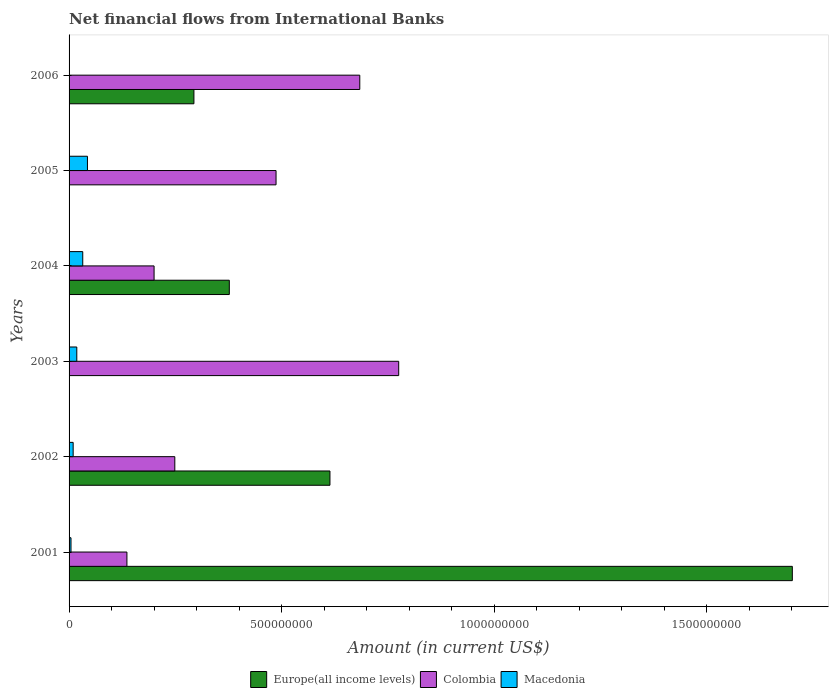How many different coloured bars are there?
Keep it short and to the point. 3. Are the number of bars on each tick of the Y-axis equal?
Offer a terse response. No. How many bars are there on the 3rd tick from the top?
Provide a short and direct response. 3. In how many cases, is the number of bars for a given year not equal to the number of legend labels?
Your response must be concise. 3. What is the net financial aid flows in Europe(all income levels) in 2006?
Offer a very short reply. 2.94e+08. Across all years, what is the maximum net financial aid flows in Macedonia?
Provide a succinct answer. 4.32e+07. Across all years, what is the minimum net financial aid flows in Colombia?
Give a very brief answer. 1.36e+08. What is the total net financial aid flows in Macedonia in the graph?
Your response must be concise. 1.08e+08. What is the difference between the net financial aid flows in Colombia in 2002 and that in 2005?
Your answer should be compact. -2.38e+08. What is the difference between the net financial aid flows in Macedonia in 2004 and the net financial aid flows in Colombia in 2006?
Provide a succinct answer. -6.52e+08. What is the average net financial aid flows in Macedonia per year?
Your response must be concise. 1.80e+07. In the year 2001, what is the difference between the net financial aid flows in Colombia and net financial aid flows in Macedonia?
Give a very brief answer. 1.32e+08. What is the ratio of the net financial aid flows in Macedonia in 2001 to that in 2005?
Your response must be concise. 0.1. What is the difference between the highest and the second highest net financial aid flows in Colombia?
Offer a terse response. 9.16e+07. What is the difference between the highest and the lowest net financial aid flows in Colombia?
Give a very brief answer. 6.39e+08. Is the sum of the net financial aid flows in Colombia in 2002 and 2006 greater than the maximum net financial aid flows in Macedonia across all years?
Provide a succinct answer. Yes. How many bars are there?
Your answer should be compact. 15. How many years are there in the graph?
Ensure brevity in your answer.  6. What is the difference between two consecutive major ticks on the X-axis?
Make the answer very short. 5.00e+08. Are the values on the major ticks of X-axis written in scientific E-notation?
Offer a terse response. No. Where does the legend appear in the graph?
Your answer should be compact. Bottom center. How many legend labels are there?
Offer a very short reply. 3. How are the legend labels stacked?
Give a very brief answer. Horizontal. What is the title of the graph?
Make the answer very short. Net financial flows from International Banks. What is the label or title of the X-axis?
Your response must be concise. Amount (in current US$). What is the label or title of the Y-axis?
Your answer should be compact. Years. What is the Amount (in current US$) of Europe(all income levels) in 2001?
Your answer should be very brief. 1.70e+09. What is the Amount (in current US$) in Colombia in 2001?
Ensure brevity in your answer.  1.36e+08. What is the Amount (in current US$) in Macedonia in 2001?
Offer a very short reply. 4.52e+06. What is the Amount (in current US$) in Europe(all income levels) in 2002?
Provide a short and direct response. 6.14e+08. What is the Amount (in current US$) in Colombia in 2002?
Ensure brevity in your answer.  2.49e+08. What is the Amount (in current US$) of Macedonia in 2002?
Provide a succinct answer. 9.62e+06. What is the Amount (in current US$) of Colombia in 2003?
Offer a very short reply. 7.75e+08. What is the Amount (in current US$) in Macedonia in 2003?
Provide a succinct answer. 1.82e+07. What is the Amount (in current US$) in Europe(all income levels) in 2004?
Make the answer very short. 3.77e+08. What is the Amount (in current US$) of Colombia in 2004?
Offer a very short reply. 2.00e+08. What is the Amount (in current US$) of Macedonia in 2004?
Offer a terse response. 3.22e+07. What is the Amount (in current US$) of Europe(all income levels) in 2005?
Your response must be concise. 0. What is the Amount (in current US$) of Colombia in 2005?
Your answer should be very brief. 4.87e+08. What is the Amount (in current US$) of Macedonia in 2005?
Keep it short and to the point. 4.32e+07. What is the Amount (in current US$) of Europe(all income levels) in 2006?
Provide a succinct answer. 2.94e+08. What is the Amount (in current US$) in Colombia in 2006?
Offer a very short reply. 6.84e+08. What is the Amount (in current US$) in Macedonia in 2006?
Give a very brief answer. 0. Across all years, what is the maximum Amount (in current US$) of Europe(all income levels)?
Your response must be concise. 1.70e+09. Across all years, what is the maximum Amount (in current US$) in Colombia?
Ensure brevity in your answer.  7.75e+08. Across all years, what is the maximum Amount (in current US$) of Macedonia?
Make the answer very short. 4.32e+07. Across all years, what is the minimum Amount (in current US$) in Colombia?
Your answer should be very brief. 1.36e+08. What is the total Amount (in current US$) in Europe(all income levels) in the graph?
Give a very brief answer. 2.99e+09. What is the total Amount (in current US$) in Colombia in the graph?
Your answer should be very brief. 2.53e+09. What is the total Amount (in current US$) of Macedonia in the graph?
Provide a short and direct response. 1.08e+08. What is the difference between the Amount (in current US$) in Europe(all income levels) in 2001 and that in 2002?
Your answer should be very brief. 1.09e+09. What is the difference between the Amount (in current US$) of Colombia in 2001 and that in 2002?
Make the answer very short. -1.13e+08. What is the difference between the Amount (in current US$) in Macedonia in 2001 and that in 2002?
Keep it short and to the point. -5.10e+06. What is the difference between the Amount (in current US$) of Colombia in 2001 and that in 2003?
Give a very brief answer. -6.39e+08. What is the difference between the Amount (in current US$) of Macedonia in 2001 and that in 2003?
Make the answer very short. -1.37e+07. What is the difference between the Amount (in current US$) in Europe(all income levels) in 2001 and that in 2004?
Make the answer very short. 1.32e+09. What is the difference between the Amount (in current US$) in Colombia in 2001 and that in 2004?
Your answer should be very brief. -6.39e+07. What is the difference between the Amount (in current US$) in Macedonia in 2001 and that in 2004?
Make the answer very short. -2.77e+07. What is the difference between the Amount (in current US$) of Colombia in 2001 and that in 2005?
Your response must be concise. -3.51e+08. What is the difference between the Amount (in current US$) of Macedonia in 2001 and that in 2005?
Your answer should be very brief. -3.87e+07. What is the difference between the Amount (in current US$) in Europe(all income levels) in 2001 and that in 2006?
Make the answer very short. 1.41e+09. What is the difference between the Amount (in current US$) in Colombia in 2001 and that in 2006?
Your answer should be very brief. -5.48e+08. What is the difference between the Amount (in current US$) of Colombia in 2002 and that in 2003?
Offer a very short reply. -5.27e+08. What is the difference between the Amount (in current US$) in Macedonia in 2002 and that in 2003?
Give a very brief answer. -8.56e+06. What is the difference between the Amount (in current US$) of Europe(all income levels) in 2002 and that in 2004?
Provide a short and direct response. 2.37e+08. What is the difference between the Amount (in current US$) of Colombia in 2002 and that in 2004?
Your answer should be compact. 4.88e+07. What is the difference between the Amount (in current US$) in Macedonia in 2002 and that in 2004?
Your answer should be compact. -2.26e+07. What is the difference between the Amount (in current US$) in Colombia in 2002 and that in 2005?
Provide a succinct answer. -2.38e+08. What is the difference between the Amount (in current US$) in Macedonia in 2002 and that in 2005?
Your response must be concise. -3.36e+07. What is the difference between the Amount (in current US$) of Europe(all income levels) in 2002 and that in 2006?
Give a very brief answer. 3.20e+08. What is the difference between the Amount (in current US$) in Colombia in 2002 and that in 2006?
Your answer should be compact. -4.35e+08. What is the difference between the Amount (in current US$) in Colombia in 2003 and that in 2004?
Offer a very short reply. 5.76e+08. What is the difference between the Amount (in current US$) in Macedonia in 2003 and that in 2004?
Offer a very short reply. -1.40e+07. What is the difference between the Amount (in current US$) of Colombia in 2003 and that in 2005?
Your answer should be compact. 2.89e+08. What is the difference between the Amount (in current US$) in Macedonia in 2003 and that in 2005?
Your response must be concise. -2.51e+07. What is the difference between the Amount (in current US$) of Colombia in 2003 and that in 2006?
Your answer should be compact. 9.16e+07. What is the difference between the Amount (in current US$) in Colombia in 2004 and that in 2005?
Make the answer very short. -2.87e+08. What is the difference between the Amount (in current US$) of Macedonia in 2004 and that in 2005?
Your answer should be compact. -1.10e+07. What is the difference between the Amount (in current US$) of Europe(all income levels) in 2004 and that in 2006?
Your response must be concise. 8.33e+07. What is the difference between the Amount (in current US$) in Colombia in 2004 and that in 2006?
Give a very brief answer. -4.84e+08. What is the difference between the Amount (in current US$) of Colombia in 2005 and that in 2006?
Give a very brief answer. -1.97e+08. What is the difference between the Amount (in current US$) of Europe(all income levels) in 2001 and the Amount (in current US$) of Colombia in 2002?
Provide a succinct answer. 1.45e+09. What is the difference between the Amount (in current US$) in Europe(all income levels) in 2001 and the Amount (in current US$) in Macedonia in 2002?
Ensure brevity in your answer.  1.69e+09. What is the difference between the Amount (in current US$) of Colombia in 2001 and the Amount (in current US$) of Macedonia in 2002?
Give a very brief answer. 1.26e+08. What is the difference between the Amount (in current US$) in Europe(all income levels) in 2001 and the Amount (in current US$) in Colombia in 2003?
Keep it short and to the point. 9.26e+08. What is the difference between the Amount (in current US$) in Europe(all income levels) in 2001 and the Amount (in current US$) in Macedonia in 2003?
Keep it short and to the point. 1.68e+09. What is the difference between the Amount (in current US$) in Colombia in 2001 and the Amount (in current US$) in Macedonia in 2003?
Give a very brief answer. 1.18e+08. What is the difference between the Amount (in current US$) in Europe(all income levels) in 2001 and the Amount (in current US$) in Colombia in 2004?
Your response must be concise. 1.50e+09. What is the difference between the Amount (in current US$) in Europe(all income levels) in 2001 and the Amount (in current US$) in Macedonia in 2004?
Your answer should be compact. 1.67e+09. What is the difference between the Amount (in current US$) in Colombia in 2001 and the Amount (in current US$) in Macedonia in 2004?
Keep it short and to the point. 1.04e+08. What is the difference between the Amount (in current US$) in Europe(all income levels) in 2001 and the Amount (in current US$) in Colombia in 2005?
Make the answer very short. 1.21e+09. What is the difference between the Amount (in current US$) of Europe(all income levels) in 2001 and the Amount (in current US$) of Macedonia in 2005?
Ensure brevity in your answer.  1.66e+09. What is the difference between the Amount (in current US$) of Colombia in 2001 and the Amount (in current US$) of Macedonia in 2005?
Ensure brevity in your answer.  9.29e+07. What is the difference between the Amount (in current US$) of Europe(all income levels) in 2001 and the Amount (in current US$) of Colombia in 2006?
Your response must be concise. 1.02e+09. What is the difference between the Amount (in current US$) in Europe(all income levels) in 2002 and the Amount (in current US$) in Colombia in 2003?
Provide a succinct answer. -1.62e+08. What is the difference between the Amount (in current US$) of Europe(all income levels) in 2002 and the Amount (in current US$) of Macedonia in 2003?
Give a very brief answer. 5.96e+08. What is the difference between the Amount (in current US$) of Colombia in 2002 and the Amount (in current US$) of Macedonia in 2003?
Keep it short and to the point. 2.31e+08. What is the difference between the Amount (in current US$) of Europe(all income levels) in 2002 and the Amount (in current US$) of Colombia in 2004?
Provide a short and direct response. 4.14e+08. What is the difference between the Amount (in current US$) in Europe(all income levels) in 2002 and the Amount (in current US$) in Macedonia in 2004?
Provide a short and direct response. 5.82e+08. What is the difference between the Amount (in current US$) of Colombia in 2002 and the Amount (in current US$) of Macedonia in 2004?
Your answer should be very brief. 2.17e+08. What is the difference between the Amount (in current US$) in Europe(all income levels) in 2002 and the Amount (in current US$) in Colombia in 2005?
Offer a very short reply. 1.27e+08. What is the difference between the Amount (in current US$) in Europe(all income levels) in 2002 and the Amount (in current US$) in Macedonia in 2005?
Provide a short and direct response. 5.71e+08. What is the difference between the Amount (in current US$) in Colombia in 2002 and the Amount (in current US$) in Macedonia in 2005?
Ensure brevity in your answer.  2.06e+08. What is the difference between the Amount (in current US$) of Europe(all income levels) in 2002 and the Amount (in current US$) of Colombia in 2006?
Your response must be concise. -7.02e+07. What is the difference between the Amount (in current US$) of Colombia in 2003 and the Amount (in current US$) of Macedonia in 2004?
Provide a short and direct response. 7.43e+08. What is the difference between the Amount (in current US$) in Colombia in 2003 and the Amount (in current US$) in Macedonia in 2005?
Your answer should be very brief. 7.32e+08. What is the difference between the Amount (in current US$) in Europe(all income levels) in 2004 and the Amount (in current US$) in Colombia in 2005?
Your response must be concise. -1.10e+08. What is the difference between the Amount (in current US$) in Europe(all income levels) in 2004 and the Amount (in current US$) in Macedonia in 2005?
Ensure brevity in your answer.  3.34e+08. What is the difference between the Amount (in current US$) in Colombia in 2004 and the Amount (in current US$) in Macedonia in 2005?
Give a very brief answer. 1.57e+08. What is the difference between the Amount (in current US$) of Europe(all income levels) in 2004 and the Amount (in current US$) of Colombia in 2006?
Give a very brief answer. -3.07e+08. What is the average Amount (in current US$) of Europe(all income levels) per year?
Provide a short and direct response. 4.98e+08. What is the average Amount (in current US$) in Colombia per year?
Give a very brief answer. 4.22e+08. What is the average Amount (in current US$) of Macedonia per year?
Your answer should be compact. 1.80e+07. In the year 2001, what is the difference between the Amount (in current US$) of Europe(all income levels) and Amount (in current US$) of Colombia?
Provide a short and direct response. 1.57e+09. In the year 2001, what is the difference between the Amount (in current US$) in Europe(all income levels) and Amount (in current US$) in Macedonia?
Provide a succinct answer. 1.70e+09. In the year 2001, what is the difference between the Amount (in current US$) of Colombia and Amount (in current US$) of Macedonia?
Make the answer very short. 1.32e+08. In the year 2002, what is the difference between the Amount (in current US$) of Europe(all income levels) and Amount (in current US$) of Colombia?
Give a very brief answer. 3.65e+08. In the year 2002, what is the difference between the Amount (in current US$) in Europe(all income levels) and Amount (in current US$) in Macedonia?
Ensure brevity in your answer.  6.04e+08. In the year 2002, what is the difference between the Amount (in current US$) in Colombia and Amount (in current US$) in Macedonia?
Make the answer very short. 2.39e+08. In the year 2003, what is the difference between the Amount (in current US$) in Colombia and Amount (in current US$) in Macedonia?
Your answer should be very brief. 7.57e+08. In the year 2004, what is the difference between the Amount (in current US$) of Europe(all income levels) and Amount (in current US$) of Colombia?
Ensure brevity in your answer.  1.77e+08. In the year 2004, what is the difference between the Amount (in current US$) in Europe(all income levels) and Amount (in current US$) in Macedonia?
Make the answer very short. 3.45e+08. In the year 2004, what is the difference between the Amount (in current US$) in Colombia and Amount (in current US$) in Macedonia?
Ensure brevity in your answer.  1.68e+08. In the year 2005, what is the difference between the Amount (in current US$) in Colombia and Amount (in current US$) in Macedonia?
Make the answer very short. 4.44e+08. In the year 2006, what is the difference between the Amount (in current US$) of Europe(all income levels) and Amount (in current US$) of Colombia?
Your answer should be compact. -3.90e+08. What is the ratio of the Amount (in current US$) of Europe(all income levels) in 2001 to that in 2002?
Keep it short and to the point. 2.77. What is the ratio of the Amount (in current US$) of Colombia in 2001 to that in 2002?
Your response must be concise. 0.55. What is the ratio of the Amount (in current US$) in Macedonia in 2001 to that in 2002?
Provide a short and direct response. 0.47. What is the ratio of the Amount (in current US$) of Colombia in 2001 to that in 2003?
Ensure brevity in your answer.  0.18. What is the ratio of the Amount (in current US$) of Macedonia in 2001 to that in 2003?
Your answer should be very brief. 0.25. What is the ratio of the Amount (in current US$) of Europe(all income levels) in 2001 to that in 2004?
Your response must be concise. 4.51. What is the ratio of the Amount (in current US$) of Colombia in 2001 to that in 2004?
Give a very brief answer. 0.68. What is the ratio of the Amount (in current US$) in Macedonia in 2001 to that in 2004?
Ensure brevity in your answer.  0.14. What is the ratio of the Amount (in current US$) of Colombia in 2001 to that in 2005?
Ensure brevity in your answer.  0.28. What is the ratio of the Amount (in current US$) in Macedonia in 2001 to that in 2005?
Your response must be concise. 0.1. What is the ratio of the Amount (in current US$) of Europe(all income levels) in 2001 to that in 2006?
Ensure brevity in your answer.  5.79. What is the ratio of the Amount (in current US$) in Colombia in 2001 to that in 2006?
Provide a succinct answer. 0.2. What is the ratio of the Amount (in current US$) in Colombia in 2002 to that in 2003?
Provide a succinct answer. 0.32. What is the ratio of the Amount (in current US$) in Macedonia in 2002 to that in 2003?
Ensure brevity in your answer.  0.53. What is the ratio of the Amount (in current US$) of Europe(all income levels) in 2002 to that in 2004?
Keep it short and to the point. 1.63. What is the ratio of the Amount (in current US$) in Colombia in 2002 to that in 2004?
Your answer should be very brief. 1.24. What is the ratio of the Amount (in current US$) in Macedonia in 2002 to that in 2004?
Offer a very short reply. 0.3. What is the ratio of the Amount (in current US$) in Colombia in 2002 to that in 2005?
Your response must be concise. 0.51. What is the ratio of the Amount (in current US$) of Macedonia in 2002 to that in 2005?
Give a very brief answer. 0.22. What is the ratio of the Amount (in current US$) of Europe(all income levels) in 2002 to that in 2006?
Your answer should be very brief. 2.09. What is the ratio of the Amount (in current US$) of Colombia in 2002 to that in 2006?
Give a very brief answer. 0.36. What is the ratio of the Amount (in current US$) in Colombia in 2003 to that in 2004?
Your answer should be very brief. 3.88. What is the ratio of the Amount (in current US$) in Macedonia in 2003 to that in 2004?
Your answer should be very brief. 0.56. What is the ratio of the Amount (in current US$) of Colombia in 2003 to that in 2005?
Offer a very short reply. 1.59. What is the ratio of the Amount (in current US$) in Macedonia in 2003 to that in 2005?
Give a very brief answer. 0.42. What is the ratio of the Amount (in current US$) in Colombia in 2003 to that in 2006?
Make the answer very short. 1.13. What is the ratio of the Amount (in current US$) of Colombia in 2004 to that in 2005?
Offer a terse response. 0.41. What is the ratio of the Amount (in current US$) in Macedonia in 2004 to that in 2005?
Keep it short and to the point. 0.74. What is the ratio of the Amount (in current US$) of Europe(all income levels) in 2004 to that in 2006?
Keep it short and to the point. 1.28. What is the ratio of the Amount (in current US$) in Colombia in 2004 to that in 2006?
Your answer should be compact. 0.29. What is the ratio of the Amount (in current US$) of Colombia in 2005 to that in 2006?
Offer a terse response. 0.71. What is the difference between the highest and the second highest Amount (in current US$) of Europe(all income levels)?
Your response must be concise. 1.09e+09. What is the difference between the highest and the second highest Amount (in current US$) in Colombia?
Ensure brevity in your answer.  9.16e+07. What is the difference between the highest and the second highest Amount (in current US$) in Macedonia?
Your response must be concise. 1.10e+07. What is the difference between the highest and the lowest Amount (in current US$) of Europe(all income levels)?
Give a very brief answer. 1.70e+09. What is the difference between the highest and the lowest Amount (in current US$) in Colombia?
Keep it short and to the point. 6.39e+08. What is the difference between the highest and the lowest Amount (in current US$) in Macedonia?
Give a very brief answer. 4.32e+07. 